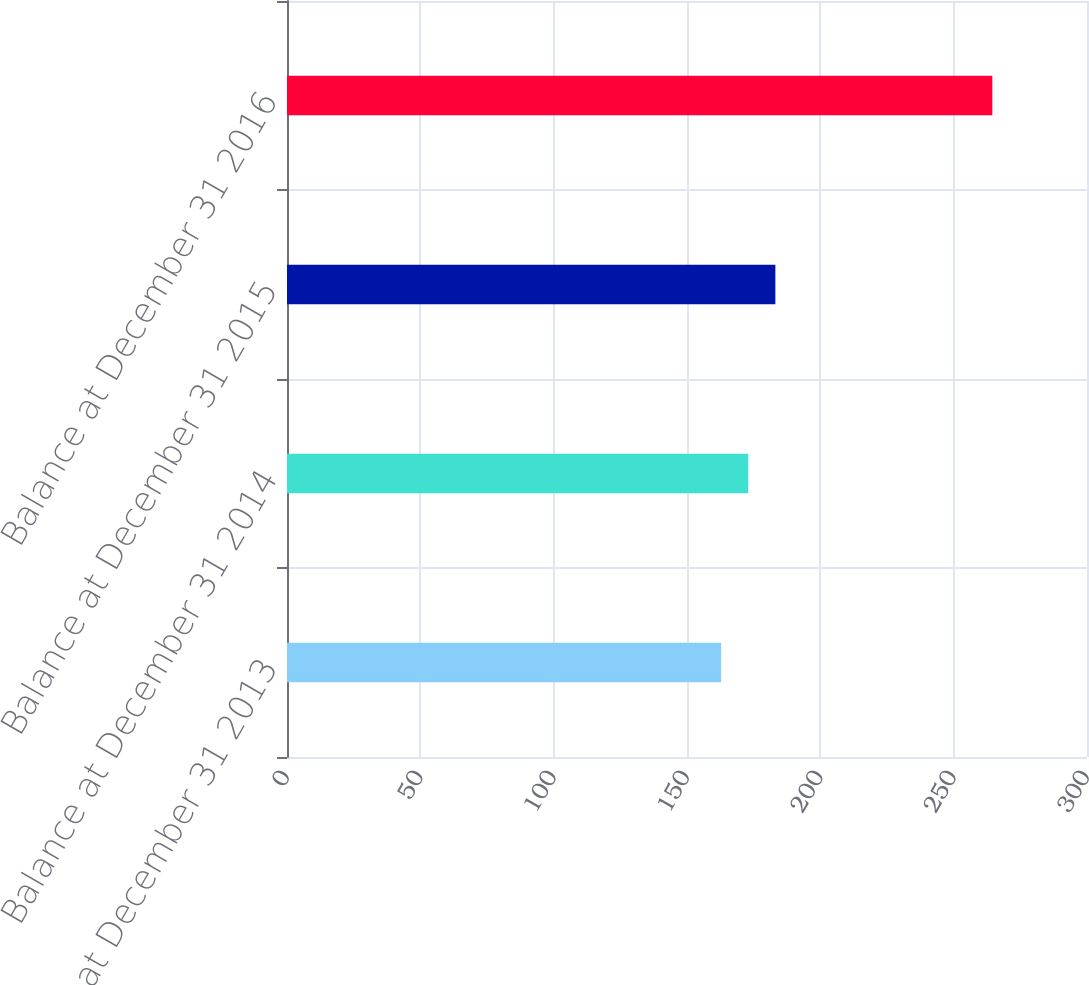Convert chart to OTSL. <chart><loc_0><loc_0><loc_500><loc_500><bar_chart><fcel>Balance at December 31 2013<fcel>Balance at December 31 2014<fcel>Balance at December 31 2015<fcel>Balance at December 31 2016<nl><fcel>162.8<fcel>172.97<fcel>183.14<fcel>264.5<nl></chart> 